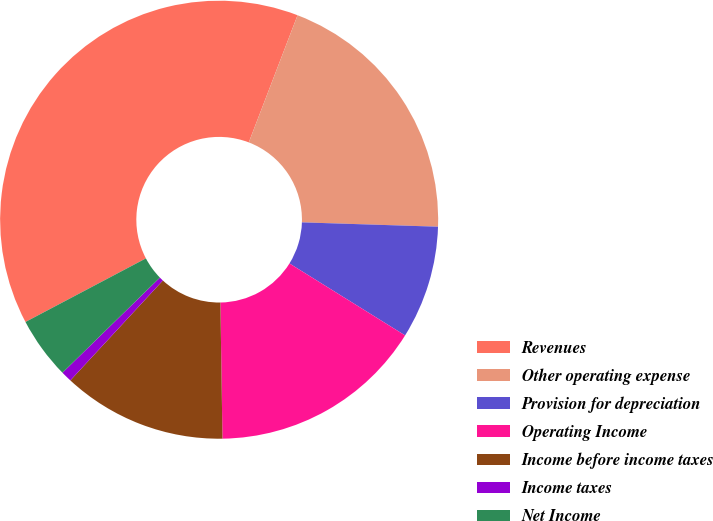<chart> <loc_0><loc_0><loc_500><loc_500><pie_chart><fcel>Revenues<fcel>Other operating expense<fcel>Provision for depreciation<fcel>Operating Income<fcel>Income before income taxes<fcel>Income taxes<fcel>Net Income<nl><fcel>38.56%<fcel>19.68%<fcel>8.35%<fcel>15.9%<fcel>12.13%<fcel>0.8%<fcel>4.58%<nl></chart> 